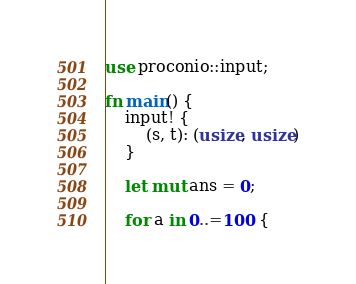<code> <loc_0><loc_0><loc_500><loc_500><_Rust_>use proconio::input;

fn main() {
    input! {
        (s, t): (usize, usize)
    }

    let mut ans = 0;

    for a in 0..=100 {</code> 